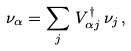<formula> <loc_0><loc_0><loc_500><loc_500>\nu _ { \alpha } = \sum _ { j } \, V _ { \alpha j } ^ { \dagger } \, \nu _ { j } \, ,</formula> 